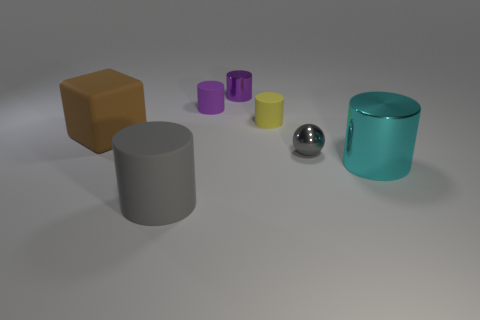Is there anything else that is the same shape as the tiny gray thing?
Give a very brief answer. No. There is a cyan object that is the same shape as the yellow thing; what is its material?
Your answer should be very brief. Metal. There is a thing left of the large cylinder that is to the left of the small yellow matte thing; is there a big matte object that is in front of it?
Your answer should be very brief. Yes. There is a large object in front of the big cyan shiny thing; does it have the same shape as the thing on the right side of the small ball?
Your response must be concise. Yes. Are there more small objects behind the brown object than small gray cylinders?
Provide a short and direct response. Yes. What number of objects are small purple shiny things or purple cylinders?
Make the answer very short. 2. The matte block is what color?
Offer a very short reply. Brown. How many other objects are there of the same color as the shiny ball?
Keep it short and to the point. 1. Are there any metal cylinders left of the shiny ball?
Your answer should be compact. Yes. There is a metal cylinder that is in front of the shiny cylinder behind the large object behind the large metallic cylinder; what color is it?
Offer a very short reply. Cyan. 